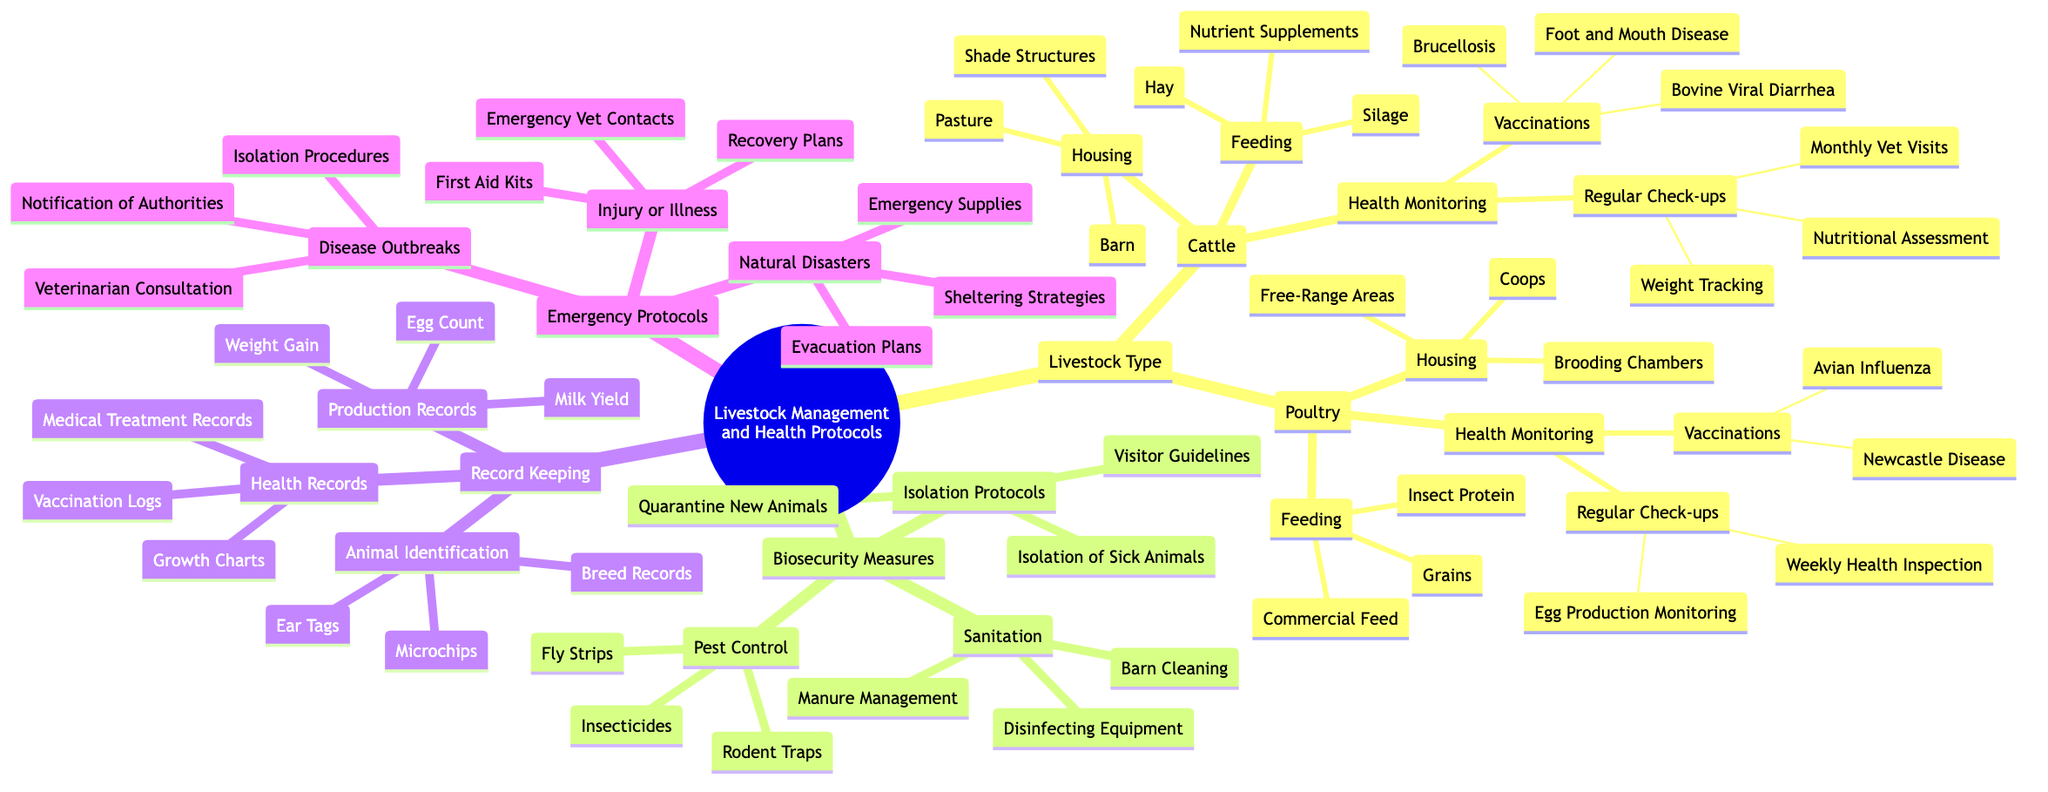What are the vaccinations for Cattle? The diagram lists the vaccinations for Cattle under the "Health Monitoring" section. The specified vaccinations are "Brucellosis," "Bovine Viral Diarrhea," and "Foot and Mouth Disease."
Answer: Brucellosis, Bovine Viral Diarrhea, Foot and Mouth Disease How many regular check-ups are listed for Poultry? In the "Health Monitoring" section for Poultry, there are two types of regular check-ups: "Weekly Health Inspection" and "Egg Production Monitoring." Therefore, the total number is two.
Answer: 2 What type of housing is recommended for Cattle? The diagram indicates the types of housing for Cattle. This includes "Barn," "Pasture," and "Shade Structures."
Answer: Barn, Pasture, Shade Structures What is included in the sanitation measures? The diagram includes three specific measures under "Sanitation" in the "Biosecurity Measures" section: "Barn Cleaning," "Disinfecting Equipment," and "Manure Management."
Answer: Barn Cleaning, Disinfecting Equipment, Manure Management What action is advised during a disease outbreak? Under the "Emergency Protocols" for "Disease Outbreaks," the diagram specifies three actions: "Isolation Procedures," "Notification of Authorities," and "Veterinarian Consultation." This indicates multiple steps in the protocol to handle disease outbreaks.
Answer: Isolation Procedures, Notification of Authorities, Veterinarian Consultation How are animals identified according to the diagram? The "Animal Identification" section in "Record Keeping" details three methods: "Ear Tags," "Microchips," and "Breed Records." These methods help in tracking and managing livestock.
Answer: Ear Tags, Microchips, Breed Records What is a common feeding option for Poultry? The diagram lists several feeding options for Poultry, including "Commercial Feed," "Grains," and "Insect Protein." Any of these would be a valid answer, but one common option is "Commercial Feed."
Answer: Commercial Feed Which emergency plan is associated with natural disasters? The diagram categorizes emergency protocols. Under "Natural Disasters," it lists "Evacuation Plans," "Emergency Supplies," and "Sheltering Strategies" as related emergency measures.
Answer: Evacuation Plans What does the regular check-up for Cattle include? Within the "Health Monitoring" for Cattle, the "Regular Check-ups" comprise "Monthly Vet Visits," "Weight Tracking," and "Nutritional Assessment." This shows that multiple aspects are monitored during check-ups.
Answer: Monthly Vet Visits, Weight Tracking, Nutritional Assessment 